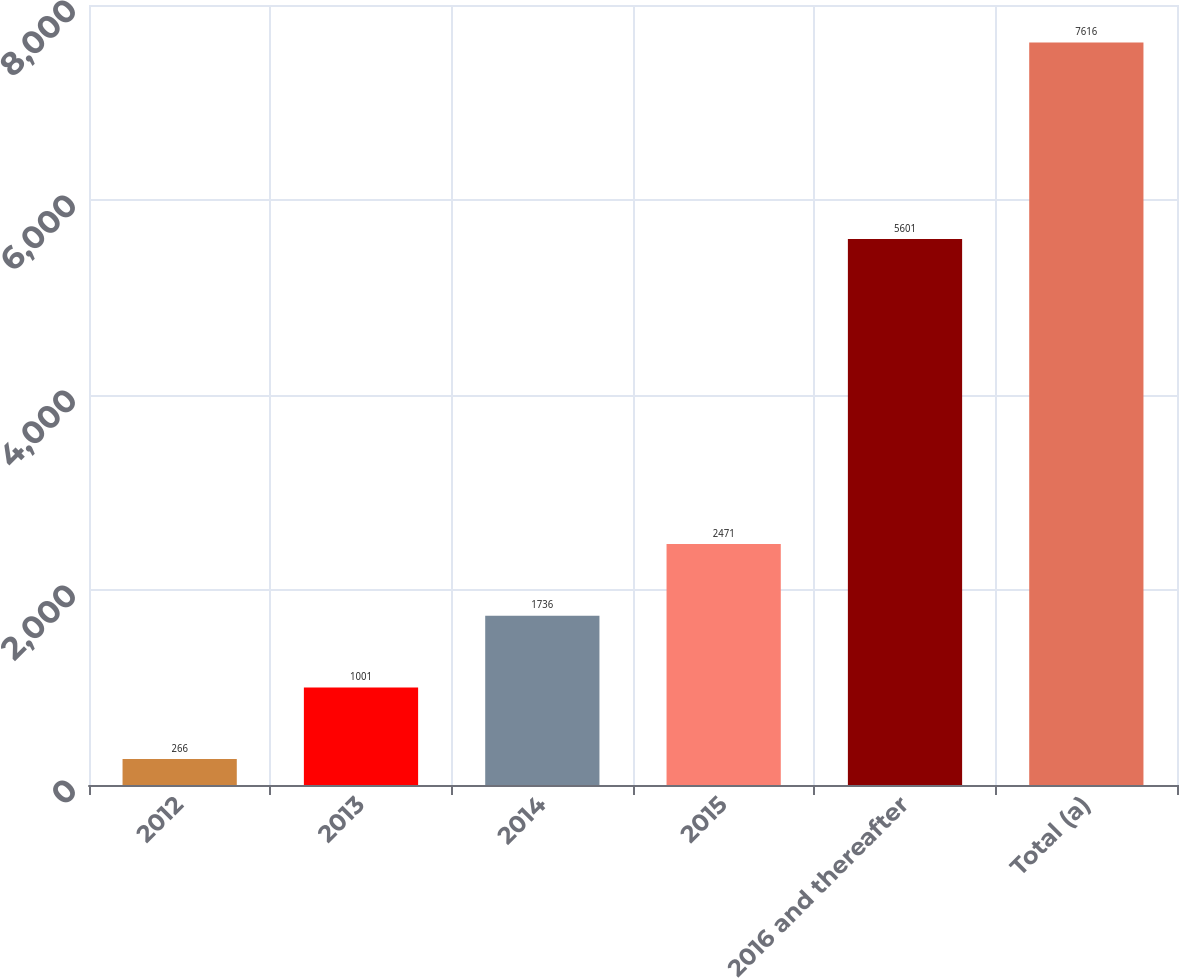Convert chart. <chart><loc_0><loc_0><loc_500><loc_500><bar_chart><fcel>2012<fcel>2013<fcel>2014<fcel>2015<fcel>2016 and thereafter<fcel>Total (a)<nl><fcel>266<fcel>1001<fcel>1736<fcel>2471<fcel>5601<fcel>7616<nl></chart> 